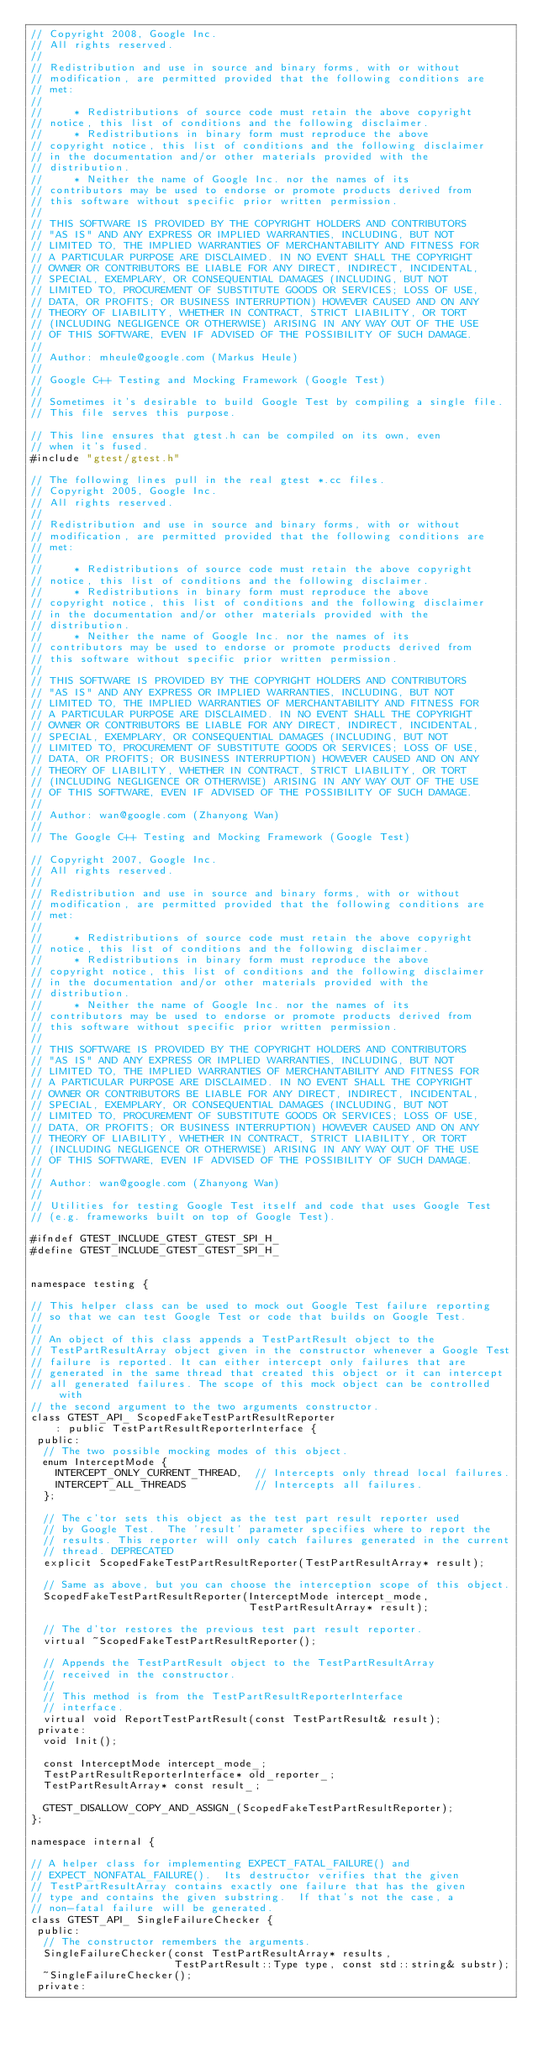Convert code to text. <code><loc_0><loc_0><loc_500><loc_500><_C++_>// Copyright 2008, Google Inc.
// All rights reserved.
//
// Redistribution and use in source and binary forms, with or without
// modification, are permitted provided that the following conditions are
// met:
//
//     * Redistributions of source code must retain the above copyright
// notice, this list of conditions and the following disclaimer.
//     * Redistributions in binary form must reproduce the above
// copyright notice, this list of conditions and the following disclaimer
// in the documentation and/or other materials provided with the
// distribution.
//     * Neither the name of Google Inc. nor the names of its
// contributors may be used to endorse or promote products derived from
// this software without specific prior written permission.
//
// THIS SOFTWARE IS PROVIDED BY THE COPYRIGHT HOLDERS AND CONTRIBUTORS
// "AS IS" AND ANY EXPRESS OR IMPLIED WARRANTIES, INCLUDING, BUT NOT
// LIMITED TO, THE IMPLIED WARRANTIES OF MERCHANTABILITY AND FITNESS FOR
// A PARTICULAR PURPOSE ARE DISCLAIMED. IN NO EVENT SHALL THE COPYRIGHT
// OWNER OR CONTRIBUTORS BE LIABLE FOR ANY DIRECT, INDIRECT, INCIDENTAL,
// SPECIAL, EXEMPLARY, OR CONSEQUENTIAL DAMAGES (INCLUDING, BUT NOT
// LIMITED TO, PROCUREMENT OF SUBSTITUTE GOODS OR SERVICES; LOSS OF USE,
// DATA, OR PROFITS; OR BUSINESS INTERRUPTION) HOWEVER CAUSED AND ON ANY
// THEORY OF LIABILITY, WHETHER IN CONTRACT, STRICT LIABILITY, OR TORT
// (INCLUDING NEGLIGENCE OR OTHERWISE) ARISING IN ANY WAY OUT OF THE USE
// OF THIS SOFTWARE, EVEN IF ADVISED OF THE POSSIBILITY OF SUCH DAMAGE.
//
// Author: mheule@google.com (Markus Heule)
//
// Google C++ Testing and Mocking Framework (Google Test)
//
// Sometimes it's desirable to build Google Test by compiling a single file.
// This file serves this purpose.

// This line ensures that gtest.h can be compiled on its own, even
// when it's fused.
#include "gtest/gtest.h"

// The following lines pull in the real gtest *.cc files.
// Copyright 2005, Google Inc.
// All rights reserved.
//
// Redistribution and use in source and binary forms, with or without
// modification, are permitted provided that the following conditions are
// met:
//
//     * Redistributions of source code must retain the above copyright
// notice, this list of conditions and the following disclaimer.
//     * Redistributions in binary form must reproduce the above
// copyright notice, this list of conditions and the following disclaimer
// in the documentation and/or other materials provided with the
// distribution.
//     * Neither the name of Google Inc. nor the names of its
// contributors may be used to endorse or promote products derived from
// this software without specific prior written permission.
//
// THIS SOFTWARE IS PROVIDED BY THE COPYRIGHT HOLDERS AND CONTRIBUTORS
// "AS IS" AND ANY EXPRESS OR IMPLIED WARRANTIES, INCLUDING, BUT NOT
// LIMITED TO, THE IMPLIED WARRANTIES OF MERCHANTABILITY AND FITNESS FOR
// A PARTICULAR PURPOSE ARE DISCLAIMED. IN NO EVENT SHALL THE COPYRIGHT
// OWNER OR CONTRIBUTORS BE LIABLE FOR ANY DIRECT, INDIRECT, INCIDENTAL,
// SPECIAL, EXEMPLARY, OR CONSEQUENTIAL DAMAGES (INCLUDING, BUT NOT
// LIMITED TO, PROCUREMENT OF SUBSTITUTE GOODS OR SERVICES; LOSS OF USE,
// DATA, OR PROFITS; OR BUSINESS INTERRUPTION) HOWEVER CAUSED AND ON ANY
// THEORY OF LIABILITY, WHETHER IN CONTRACT, STRICT LIABILITY, OR TORT
// (INCLUDING NEGLIGENCE OR OTHERWISE) ARISING IN ANY WAY OUT OF THE USE
// OF THIS SOFTWARE, EVEN IF ADVISED OF THE POSSIBILITY OF SUCH DAMAGE.
//
// Author: wan@google.com (Zhanyong Wan)
//
// The Google C++ Testing and Mocking Framework (Google Test)

// Copyright 2007, Google Inc.
// All rights reserved.
//
// Redistribution and use in source and binary forms, with or without
// modification, are permitted provided that the following conditions are
// met:
//
//     * Redistributions of source code must retain the above copyright
// notice, this list of conditions and the following disclaimer.
//     * Redistributions in binary form must reproduce the above
// copyright notice, this list of conditions and the following disclaimer
// in the documentation and/or other materials provided with the
// distribution.
//     * Neither the name of Google Inc. nor the names of its
// contributors may be used to endorse or promote products derived from
// this software without specific prior written permission.
//
// THIS SOFTWARE IS PROVIDED BY THE COPYRIGHT HOLDERS AND CONTRIBUTORS
// "AS IS" AND ANY EXPRESS OR IMPLIED WARRANTIES, INCLUDING, BUT NOT
// LIMITED TO, THE IMPLIED WARRANTIES OF MERCHANTABILITY AND FITNESS FOR
// A PARTICULAR PURPOSE ARE DISCLAIMED. IN NO EVENT SHALL THE COPYRIGHT
// OWNER OR CONTRIBUTORS BE LIABLE FOR ANY DIRECT, INDIRECT, INCIDENTAL,
// SPECIAL, EXEMPLARY, OR CONSEQUENTIAL DAMAGES (INCLUDING, BUT NOT
// LIMITED TO, PROCUREMENT OF SUBSTITUTE GOODS OR SERVICES; LOSS OF USE,
// DATA, OR PROFITS; OR BUSINESS INTERRUPTION) HOWEVER CAUSED AND ON ANY
// THEORY OF LIABILITY, WHETHER IN CONTRACT, STRICT LIABILITY, OR TORT
// (INCLUDING NEGLIGENCE OR OTHERWISE) ARISING IN ANY WAY OUT OF THE USE
// OF THIS SOFTWARE, EVEN IF ADVISED OF THE POSSIBILITY OF SUCH DAMAGE.
//
// Author: wan@google.com (Zhanyong Wan)
//
// Utilities for testing Google Test itself and code that uses Google Test
// (e.g. frameworks built on top of Google Test).

#ifndef GTEST_INCLUDE_GTEST_GTEST_SPI_H_
#define GTEST_INCLUDE_GTEST_GTEST_SPI_H_


namespace testing {

// This helper class can be used to mock out Google Test failure reporting
// so that we can test Google Test or code that builds on Google Test.
//
// An object of this class appends a TestPartResult object to the
// TestPartResultArray object given in the constructor whenever a Google Test
// failure is reported. It can either intercept only failures that are
// generated in the same thread that created this object or it can intercept
// all generated failures. The scope of this mock object can be controlled with
// the second argument to the two arguments constructor.
class GTEST_API_ ScopedFakeTestPartResultReporter
    : public TestPartResultReporterInterface {
 public:
  // The two possible mocking modes of this object.
  enum InterceptMode {
    INTERCEPT_ONLY_CURRENT_THREAD,  // Intercepts only thread local failures.
    INTERCEPT_ALL_THREADS           // Intercepts all failures.
  };

  // The c'tor sets this object as the test part result reporter used
  // by Google Test.  The 'result' parameter specifies where to report the
  // results. This reporter will only catch failures generated in the current
  // thread. DEPRECATED
  explicit ScopedFakeTestPartResultReporter(TestPartResultArray* result);

  // Same as above, but you can choose the interception scope of this object.
  ScopedFakeTestPartResultReporter(InterceptMode intercept_mode,
                                   TestPartResultArray* result);

  // The d'tor restores the previous test part result reporter.
  virtual ~ScopedFakeTestPartResultReporter();

  // Appends the TestPartResult object to the TestPartResultArray
  // received in the constructor.
  //
  // This method is from the TestPartResultReporterInterface
  // interface.
  virtual void ReportTestPartResult(const TestPartResult& result);
 private:
  void Init();

  const InterceptMode intercept_mode_;
  TestPartResultReporterInterface* old_reporter_;
  TestPartResultArray* const result_;

  GTEST_DISALLOW_COPY_AND_ASSIGN_(ScopedFakeTestPartResultReporter);
};

namespace internal {

// A helper class for implementing EXPECT_FATAL_FAILURE() and
// EXPECT_NONFATAL_FAILURE().  Its destructor verifies that the given
// TestPartResultArray contains exactly one failure that has the given
// type and contains the given substring.  If that's not the case, a
// non-fatal failure will be generated.
class GTEST_API_ SingleFailureChecker {
 public:
  // The constructor remembers the arguments.
  SingleFailureChecker(const TestPartResultArray* results,
                       TestPartResult::Type type, const std::string& substr);
  ~SingleFailureChecker();
 private:</code> 